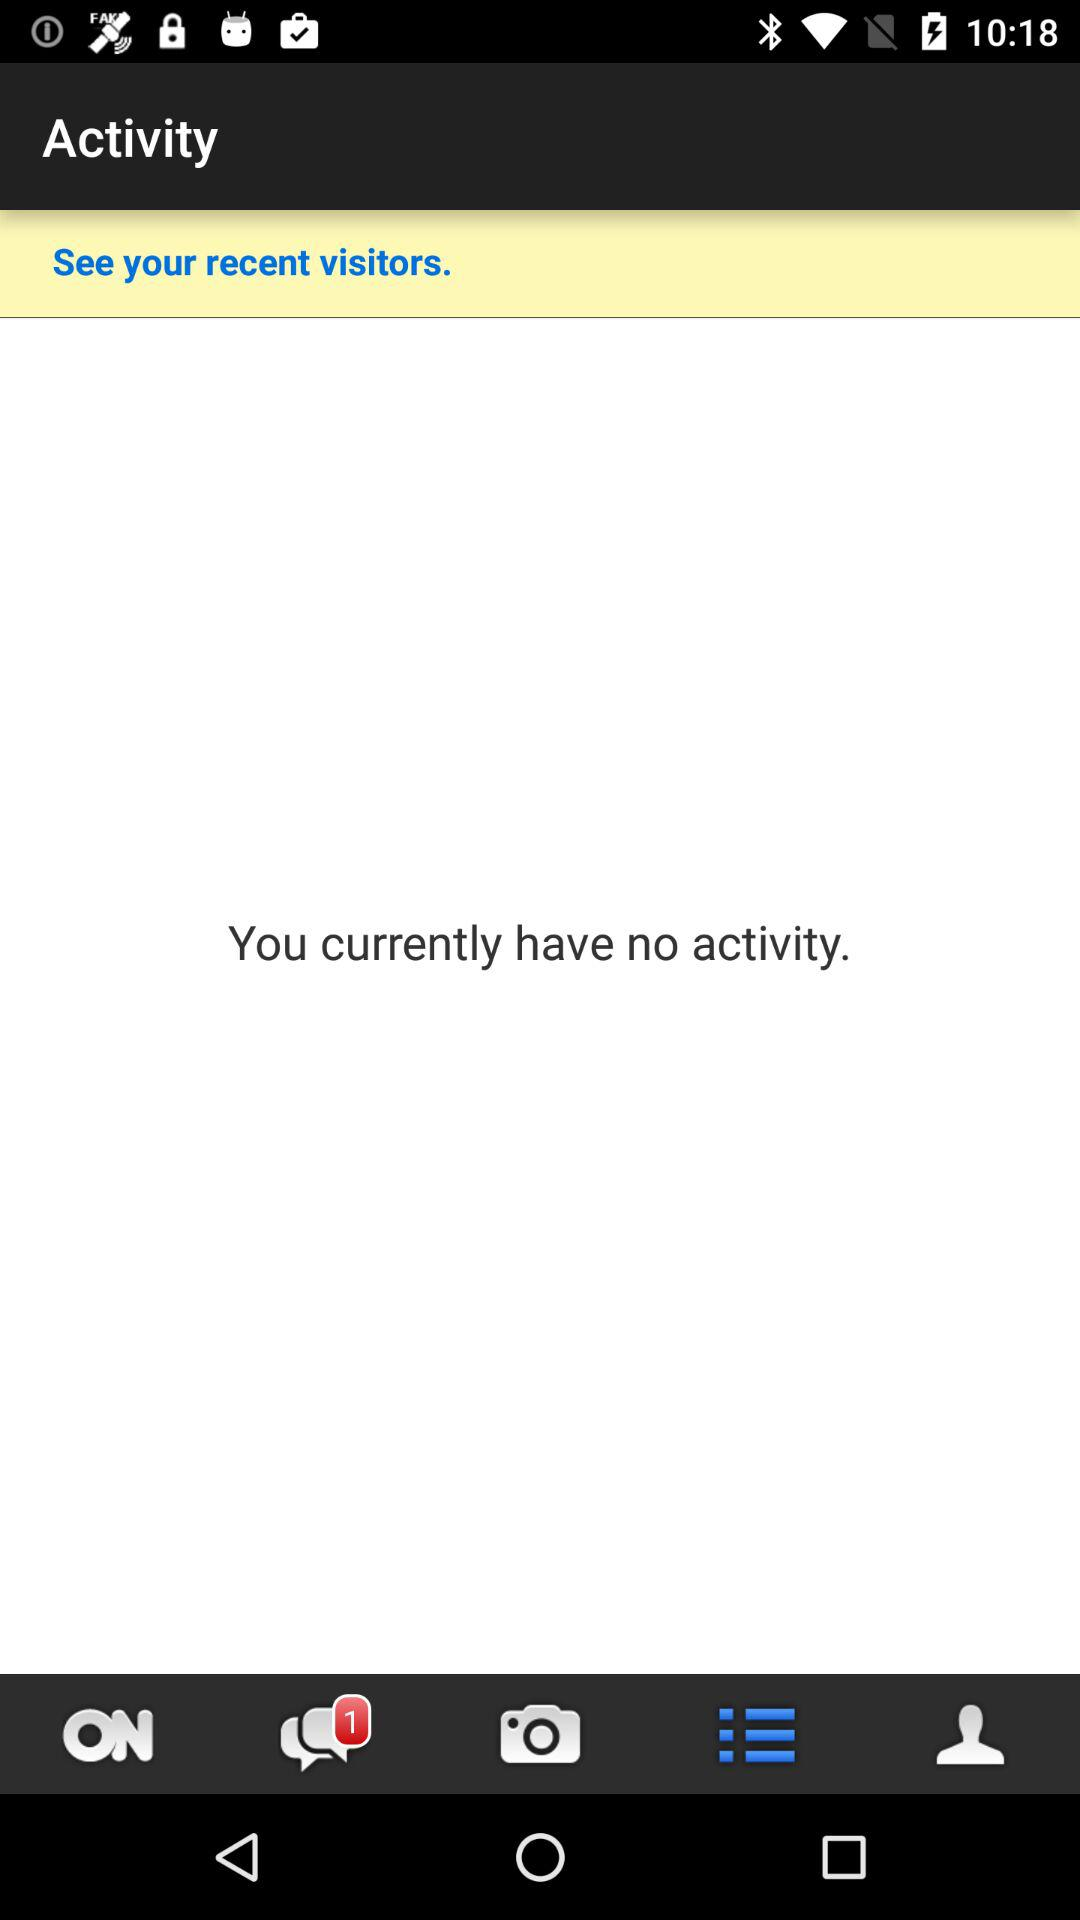Are there any unread chats? There is 1 unread chat. 